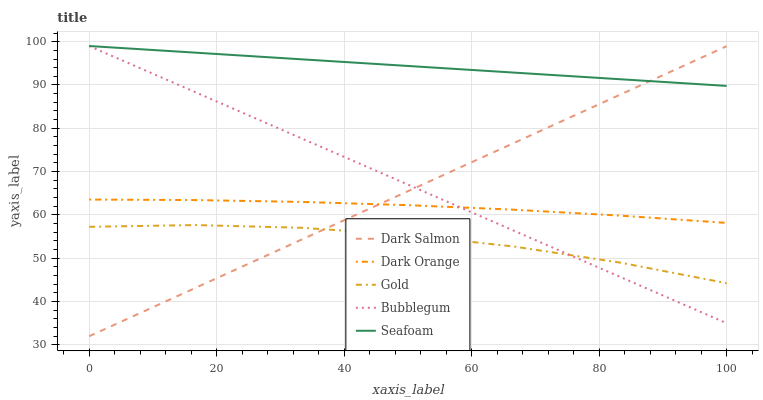Does Gold have the minimum area under the curve?
Answer yes or no. Yes. Does Seafoam have the maximum area under the curve?
Answer yes or no. Yes. Does Bubblegum have the minimum area under the curve?
Answer yes or no. No. Does Bubblegum have the maximum area under the curve?
Answer yes or no. No. Is Seafoam the smoothest?
Answer yes or no. Yes. Is Gold the roughest?
Answer yes or no. Yes. Is Bubblegum the smoothest?
Answer yes or no. No. Is Bubblegum the roughest?
Answer yes or no. No. Does Dark Salmon have the lowest value?
Answer yes or no. Yes. Does Bubblegum have the lowest value?
Answer yes or no. No. Does Seafoam have the highest value?
Answer yes or no. Yes. Does Dark Salmon have the highest value?
Answer yes or no. No. Is Gold less than Seafoam?
Answer yes or no. Yes. Is Dark Orange greater than Gold?
Answer yes or no. Yes. Does Gold intersect Bubblegum?
Answer yes or no. Yes. Is Gold less than Bubblegum?
Answer yes or no. No. Is Gold greater than Bubblegum?
Answer yes or no. No. Does Gold intersect Seafoam?
Answer yes or no. No. 